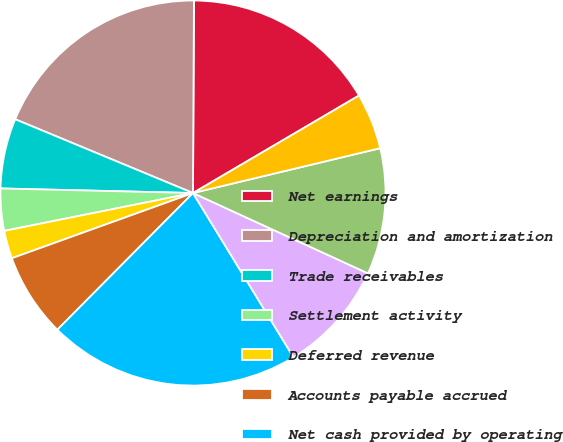<chart> <loc_0><loc_0><loc_500><loc_500><pie_chart><fcel>Net earnings<fcel>Depreciation and amortization<fcel>Trade receivables<fcel>Settlement activity<fcel>Deferred revenue<fcel>Accounts payable accrued<fcel>Net cash provided by operating<fcel>Additions to property and<fcel>Additions to computer software<fcel>Net cash used in investing<nl><fcel>16.47%<fcel>18.82%<fcel>5.88%<fcel>3.53%<fcel>2.35%<fcel>7.06%<fcel>21.18%<fcel>9.41%<fcel>10.59%<fcel>4.71%<nl></chart> 